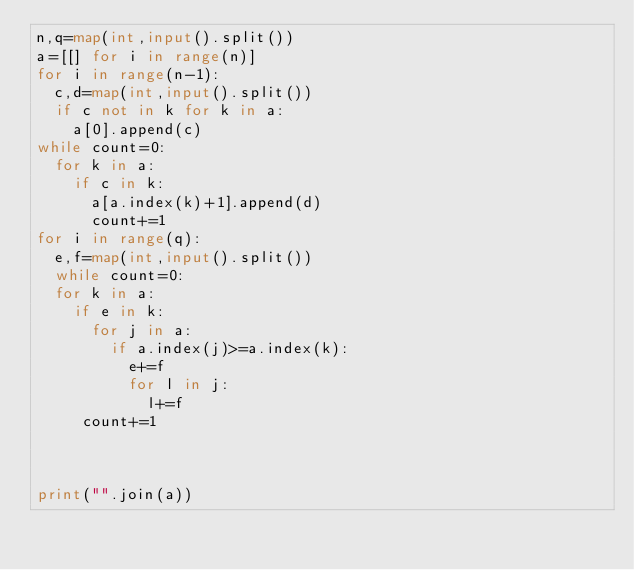Convert code to text. <code><loc_0><loc_0><loc_500><loc_500><_Python_>n,q=map(int,input().split())
a=[[] for i in range(n)]
for i in range(n-1):
  c,d=map(int,input().split())
  if c not in k for k in a:
    a[0].append(c)
while count=0:
  for k in a:
    if c in k:
      a[a.index(k)+1].append(d)
      count+=1
for i in range(q):
  e,f=map(int,input().split())
  while count=0:
  for k in a:
    if e in k:
      for j in a:
        if a.index(j)>=a.index(k):
          e+=f
          for l in j:
            l+=f
     count+=1
      
    
    
print("".join(a))
  </code> 